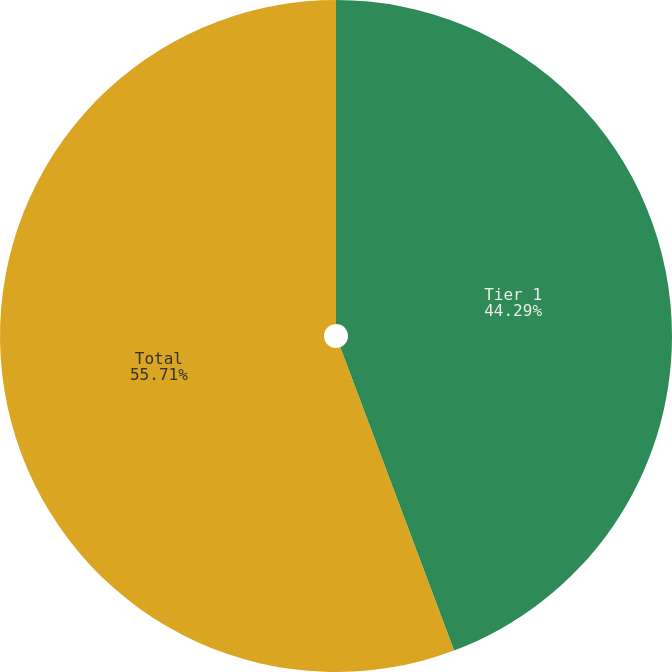Convert chart to OTSL. <chart><loc_0><loc_0><loc_500><loc_500><pie_chart><fcel>Tier 1<fcel>Total<nl><fcel>44.29%<fcel>55.71%<nl></chart> 